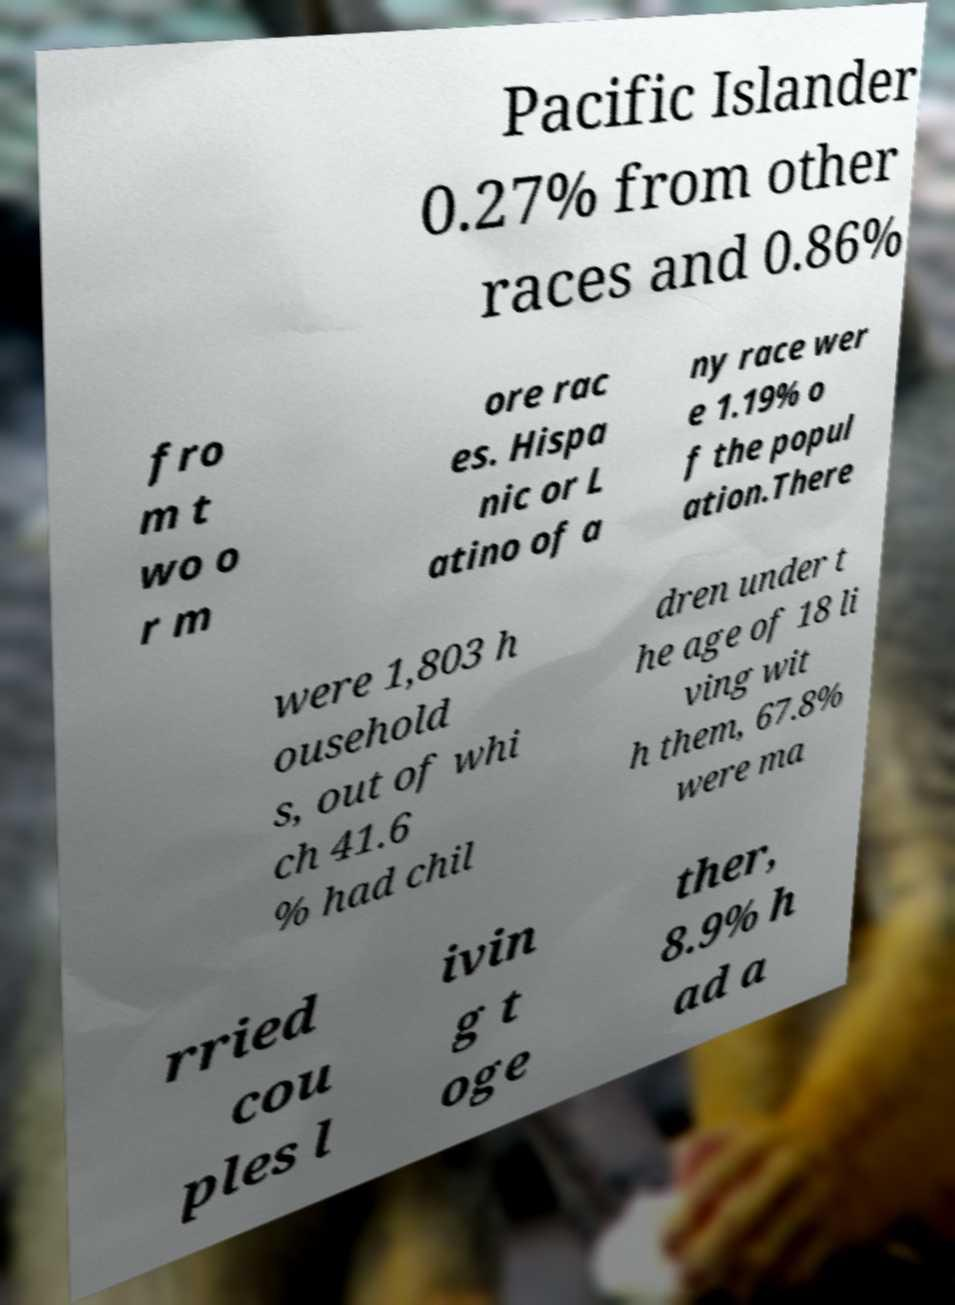What messages or text are displayed in this image? I need them in a readable, typed format. Pacific Islander 0.27% from other races and 0.86% fro m t wo o r m ore rac es. Hispa nic or L atino of a ny race wer e 1.19% o f the popul ation.There were 1,803 h ousehold s, out of whi ch 41.6 % had chil dren under t he age of 18 li ving wit h them, 67.8% were ma rried cou ples l ivin g t oge ther, 8.9% h ad a 